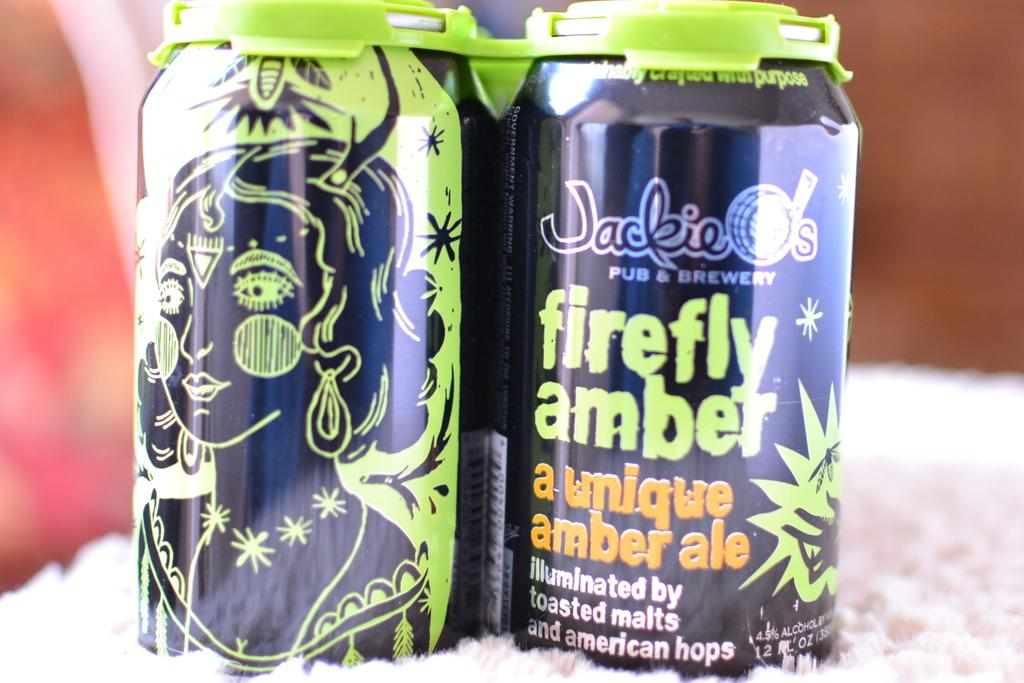<image>
Create a compact narrative representing the image presented. two cans of jackie O's firefly amber ale sit on a table 